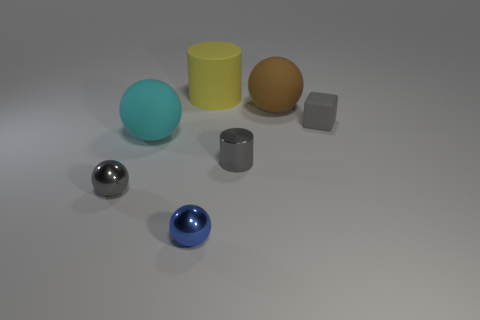Add 1 big blue objects. How many objects exist? 8 Subtract all balls. How many objects are left? 3 Subtract 0 yellow blocks. How many objects are left? 7 Subtract all tiny green metallic things. Subtract all cyan rubber spheres. How many objects are left? 6 Add 4 tiny blue balls. How many tiny blue balls are left? 5 Add 5 small gray spheres. How many small gray spheres exist? 6 